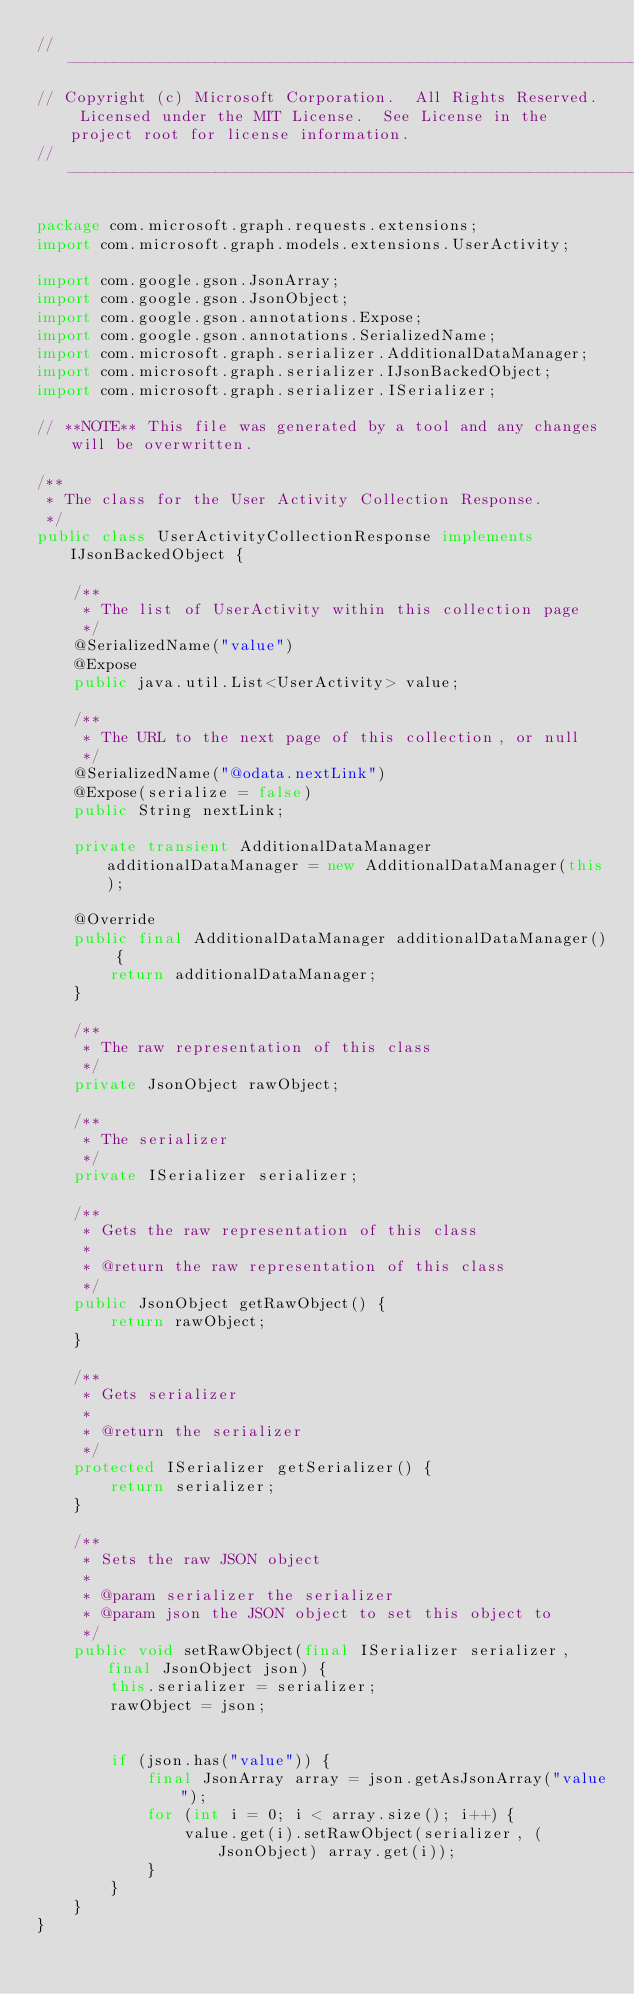Convert code to text. <code><loc_0><loc_0><loc_500><loc_500><_Java_>// ------------------------------------------------------------------------------
// Copyright (c) Microsoft Corporation.  All Rights Reserved.  Licensed under the MIT License.  See License in the project root for license information.
// ------------------------------------------------------------------------------

package com.microsoft.graph.requests.extensions;
import com.microsoft.graph.models.extensions.UserActivity;

import com.google.gson.JsonArray;
import com.google.gson.JsonObject;
import com.google.gson.annotations.Expose;
import com.google.gson.annotations.SerializedName;
import com.microsoft.graph.serializer.AdditionalDataManager;
import com.microsoft.graph.serializer.IJsonBackedObject;
import com.microsoft.graph.serializer.ISerializer;

// **NOTE** This file was generated by a tool and any changes will be overwritten.

/**
 * The class for the User Activity Collection Response.
 */
public class UserActivityCollectionResponse implements IJsonBackedObject {

    /**
     * The list of UserActivity within this collection page
     */
    @SerializedName("value")
    @Expose
    public java.util.List<UserActivity> value;

    /**
     * The URL to the next page of this collection, or null
     */
    @SerializedName("@odata.nextLink")
    @Expose(serialize = false)
    public String nextLink;

    private transient AdditionalDataManager additionalDataManager = new AdditionalDataManager(this);

    @Override
    public final AdditionalDataManager additionalDataManager() {
        return additionalDataManager;
    }

    /**
     * The raw representation of this class
     */
    private JsonObject rawObject;

    /**
     * The serializer
     */
    private ISerializer serializer;

    /**
     * Gets the raw representation of this class
     *
     * @return the raw representation of this class
     */
    public JsonObject getRawObject() {
        return rawObject;
    }

    /**
     * Gets serializer
     *
     * @return the serializer
     */
    protected ISerializer getSerializer() {
        return serializer;
    }

    /**
     * Sets the raw JSON object
     *
     * @param serializer the serializer
     * @param json the JSON object to set this object to
     */
    public void setRawObject(final ISerializer serializer, final JsonObject json) {
        this.serializer = serializer;
        rawObject = json;


        if (json.has("value")) {
            final JsonArray array = json.getAsJsonArray("value");
            for (int i = 0; i < array.size(); i++) {
                value.get(i).setRawObject(serializer, (JsonObject) array.get(i));
            }
        }
    }
}
</code> 